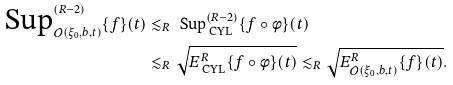<formula> <loc_0><loc_0><loc_500><loc_500>\text { Sup} ^ { ( R - 2 ) } _ { \mathcal { O } ( \xi _ { 0 } , b , t ) } \{ f \} ( t ) & \lesssim _ { R } \text { Sup} ^ { ( R - 2 ) } _ { \text { CYL} } \{ f \circ \phi \} ( t ) \\ & \lesssim _ { R } \sqrt { E ^ { R } _ { \text { CYL} } \{ f \circ \phi \} ( t ) } \lesssim _ { R } \sqrt { E ^ { R } _ { \mathcal { O } ( \xi _ { 0 } , b , t ) } \{ f \} ( t ) } .</formula> 